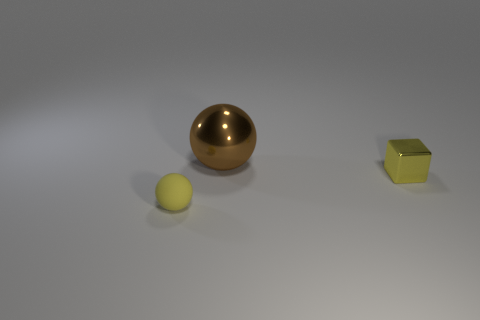Subtract all brown spheres. How many spheres are left? 1 Subtract all spheres. How many objects are left? 1 Subtract all gray balls. Subtract all blue cubes. How many balls are left? 2 Subtract all brown blocks. How many brown spheres are left? 1 Subtract all large green blocks. Subtract all big balls. How many objects are left? 2 Add 2 yellow spheres. How many yellow spheres are left? 3 Add 1 large blue matte things. How many large blue matte things exist? 1 Add 1 yellow matte spheres. How many objects exist? 4 Subtract 0 cyan blocks. How many objects are left? 3 